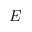<formula> <loc_0><loc_0><loc_500><loc_500>E</formula> 